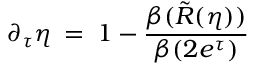<formula> <loc_0><loc_0><loc_500><loc_500>\partial _ { \tau } \eta \, = \, 1 - \frac { \beta ( \tilde { R } ( \eta ) ) } { \beta ( 2 e ^ { \tau } ) } \,</formula> 